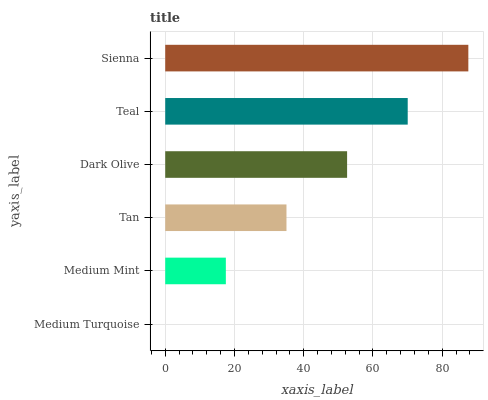Is Medium Turquoise the minimum?
Answer yes or no. Yes. Is Sienna the maximum?
Answer yes or no. Yes. Is Medium Mint the minimum?
Answer yes or no. No. Is Medium Mint the maximum?
Answer yes or no. No. Is Medium Mint greater than Medium Turquoise?
Answer yes or no. Yes. Is Medium Turquoise less than Medium Mint?
Answer yes or no. Yes. Is Medium Turquoise greater than Medium Mint?
Answer yes or no. No. Is Medium Mint less than Medium Turquoise?
Answer yes or no. No. Is Dark Olive the high median?
Answer yes or no. Yes. Is Tan the low median?
Answer yes or no. Yes. Is Sienna the high median?
Answer yes or no. No. Is Medium Mint the low median?
Answer yes or no. No. 